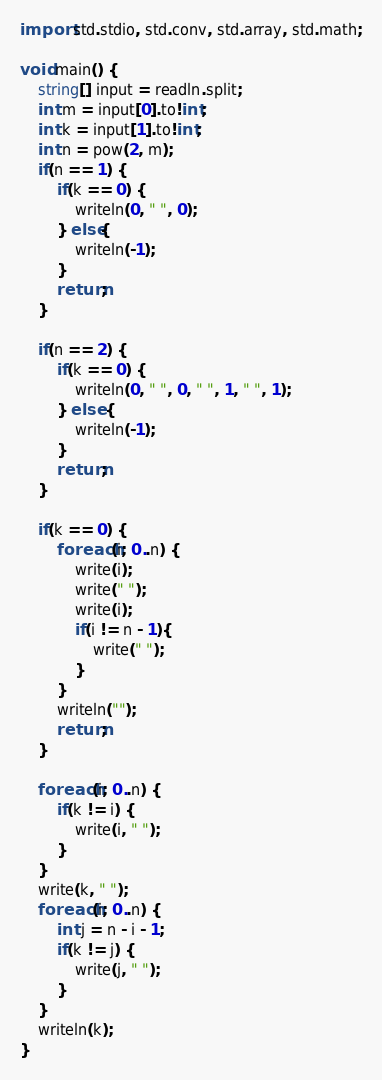Convert code to text. <code><loc_0><loc_0><loc_500><loc_500><_D_>import std.stdio, std.conv, std.array, std.math;

void main() {
    string[] input = readln.split;
    int m = input[0].to!int;
    int k = input[1].to!int;
    int n = pow(2, m);
    if(n == 1) {
        if(k == 0) {
            writeln(0, " ", 0);
        } else{
            writeln(-1);
        }
        return;
    }

    if(n == 2) {
        if(k == 0) {
            writeln(0, " ", 0, " ", 1, " ", 1);
        } else {
            writeln(-1);
        }
        return;
    }

    if(k == 0) {
        foreach(i; 0..n) {
            write(i);
            write(" ");
            write(i);
            if(i != n - 1){
                write(" ");
            }
        }
        writeln("");
        return;
    }

    foreach(i; 0..n) {
        if(k != i) {
            write(i, " ");
        }
    }
    write(k, " ");
    foreach(i; 0..n) {
        int j = n - i - 1;
        if(k != j) {
            write(j, " ");
        }
    }
    writeln(k);
}
</code> 